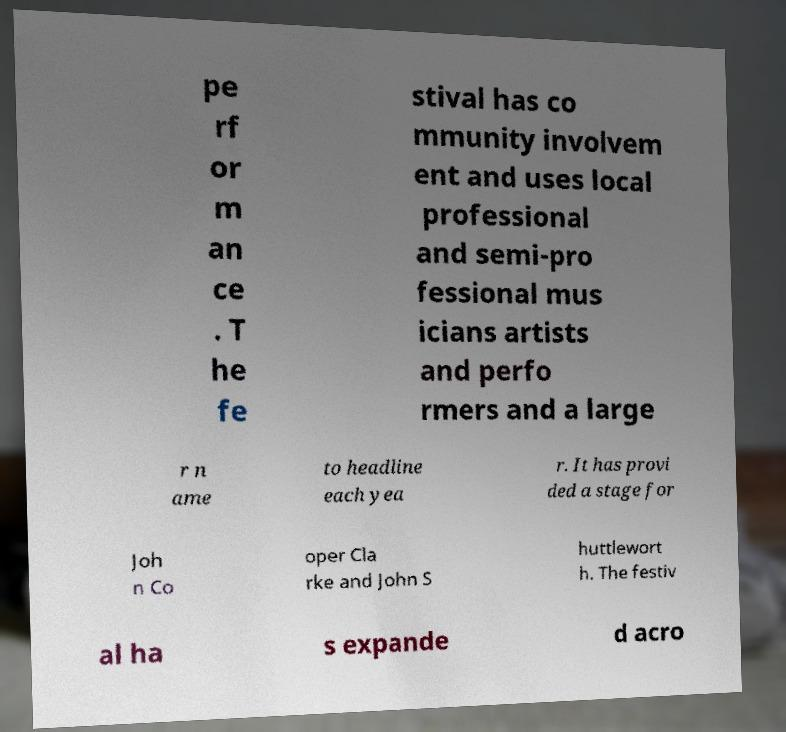For documentation purposes, I need the text within this image transcribed. Could you provide that? pe rf or m an ce . T he fe stival has co mmunity involvem ent and uses local professional and semi-pro fessional mus icians artists and perfo rmers and a large r n ame to headline each yea r. It has provi ded a stage for Joh n Co oper Cla rke and John S huttlewort h. The festiv al ha s expande d acro 